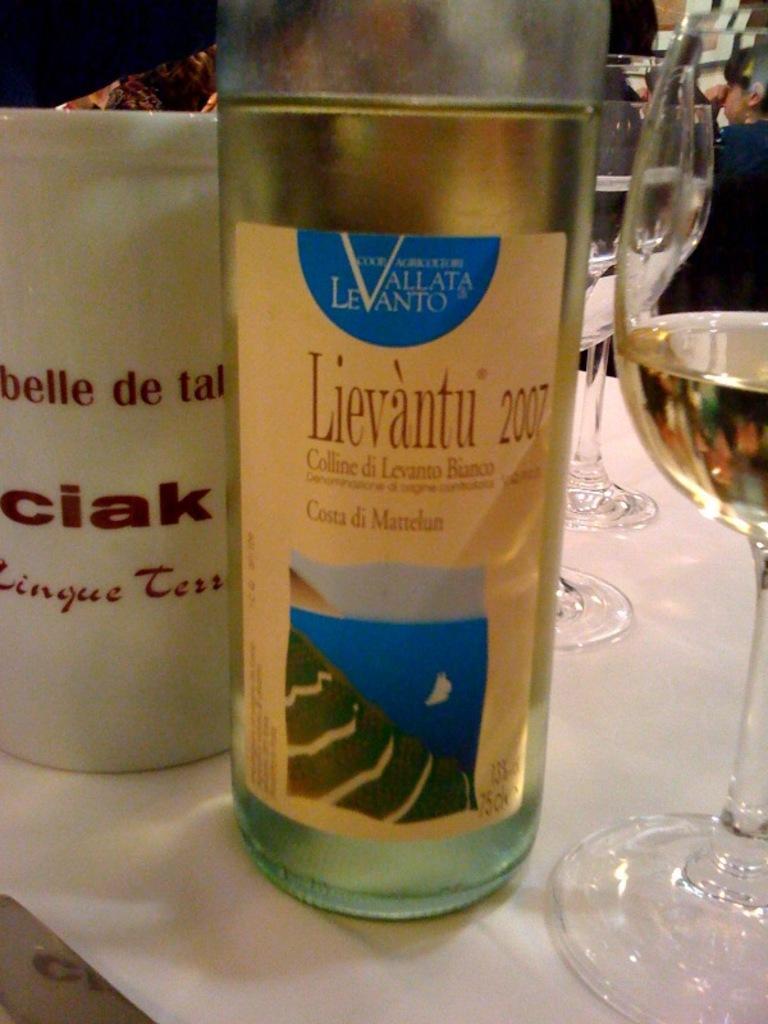How would you summarize this image in a sentence or two? We can see bottle,cup,glass with drink. On the background we can see person. 